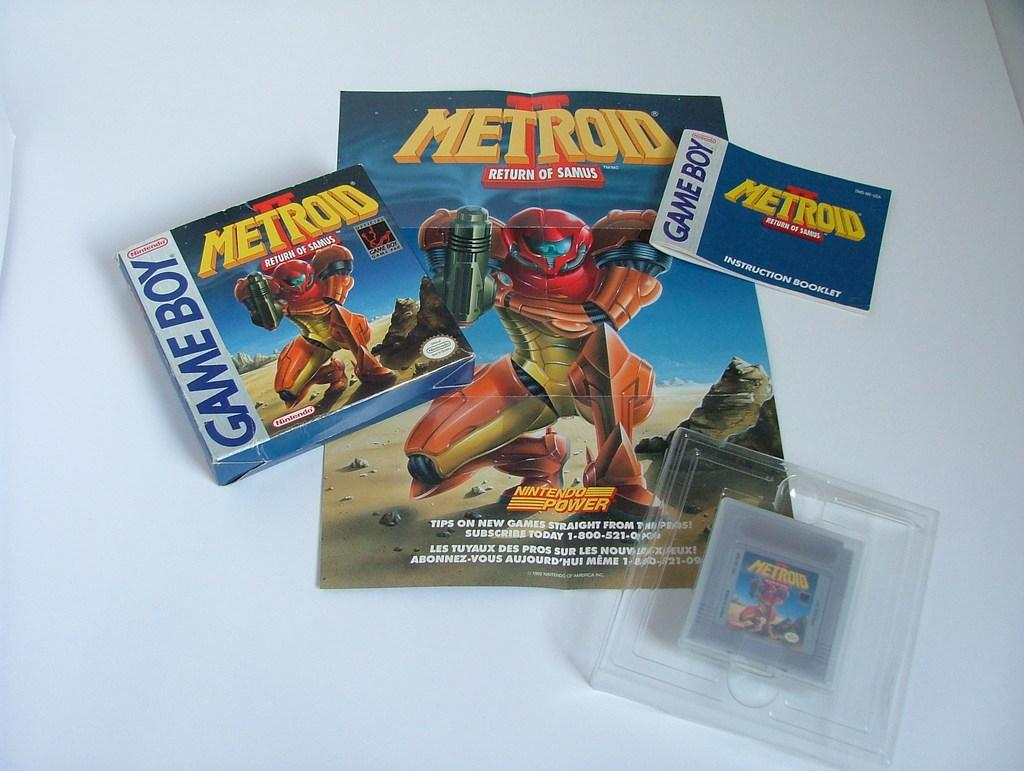What type of object can be seen in the image? There is a box in the image. What other items are present in the image? There is a pamphlet and a book in the image. Can you describe the material of one of the objects? There is a plastic box in the image. What is the color of the surface on which the objects are placed? The objects are on a white color surface. Is there a bat flying around the objects in the image? There is no bat present in the image. Can you tell me the name of the aunt who is visiting in the image? There is no mention of a visitor or an aunt in the image. 